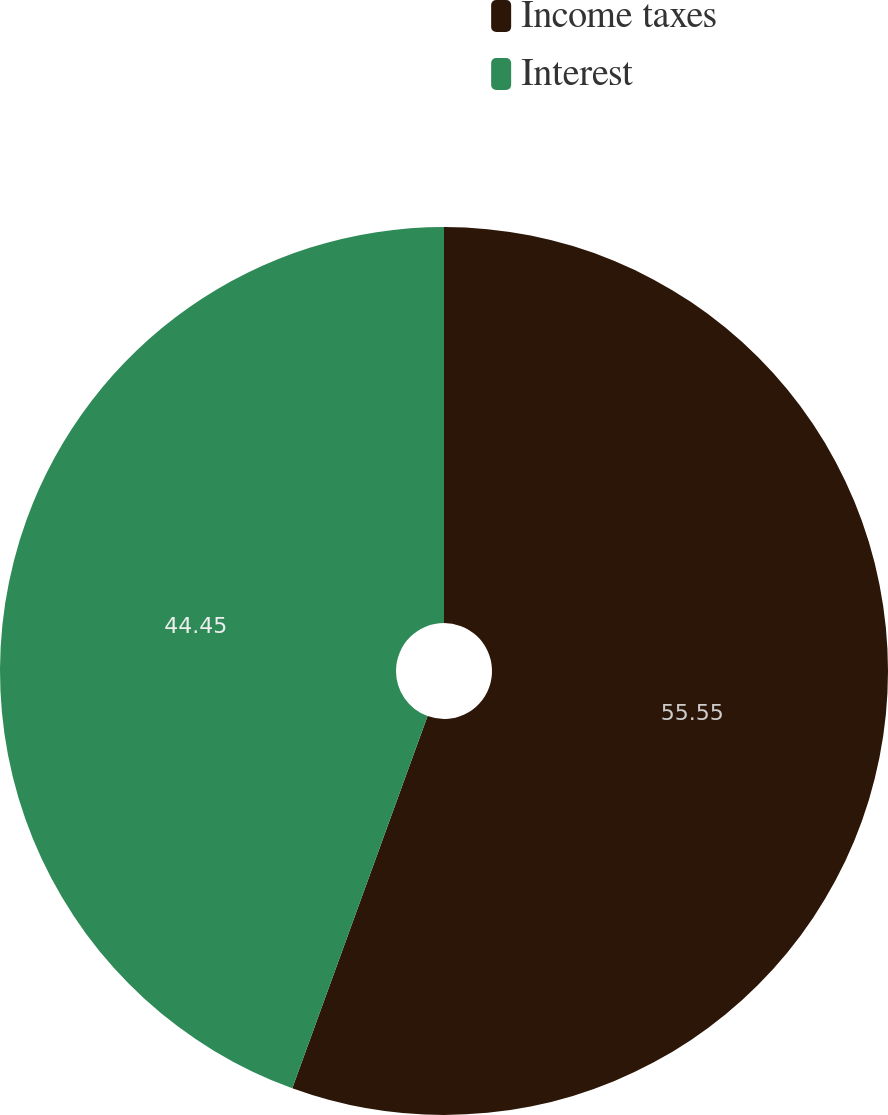<chart> <loc_0><loc_0><loc_500><loc_500><pie_chart><fcel>Income taxes<fcel>Interest<nl><fcel>55.55%<fcel>44.45%<nl></chart> 